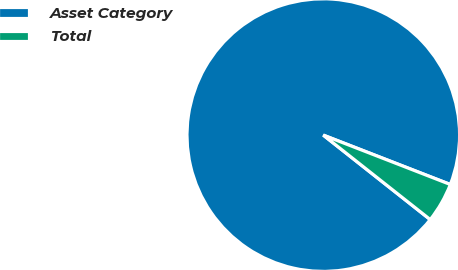Convert chart. <chart><loc_0><loc_0><loc_500><loc_500><pie_chart><fcel>Asset Category<fcel>Total<nl><fcel>95.26%<fcel>4.74%<nl></chart> 